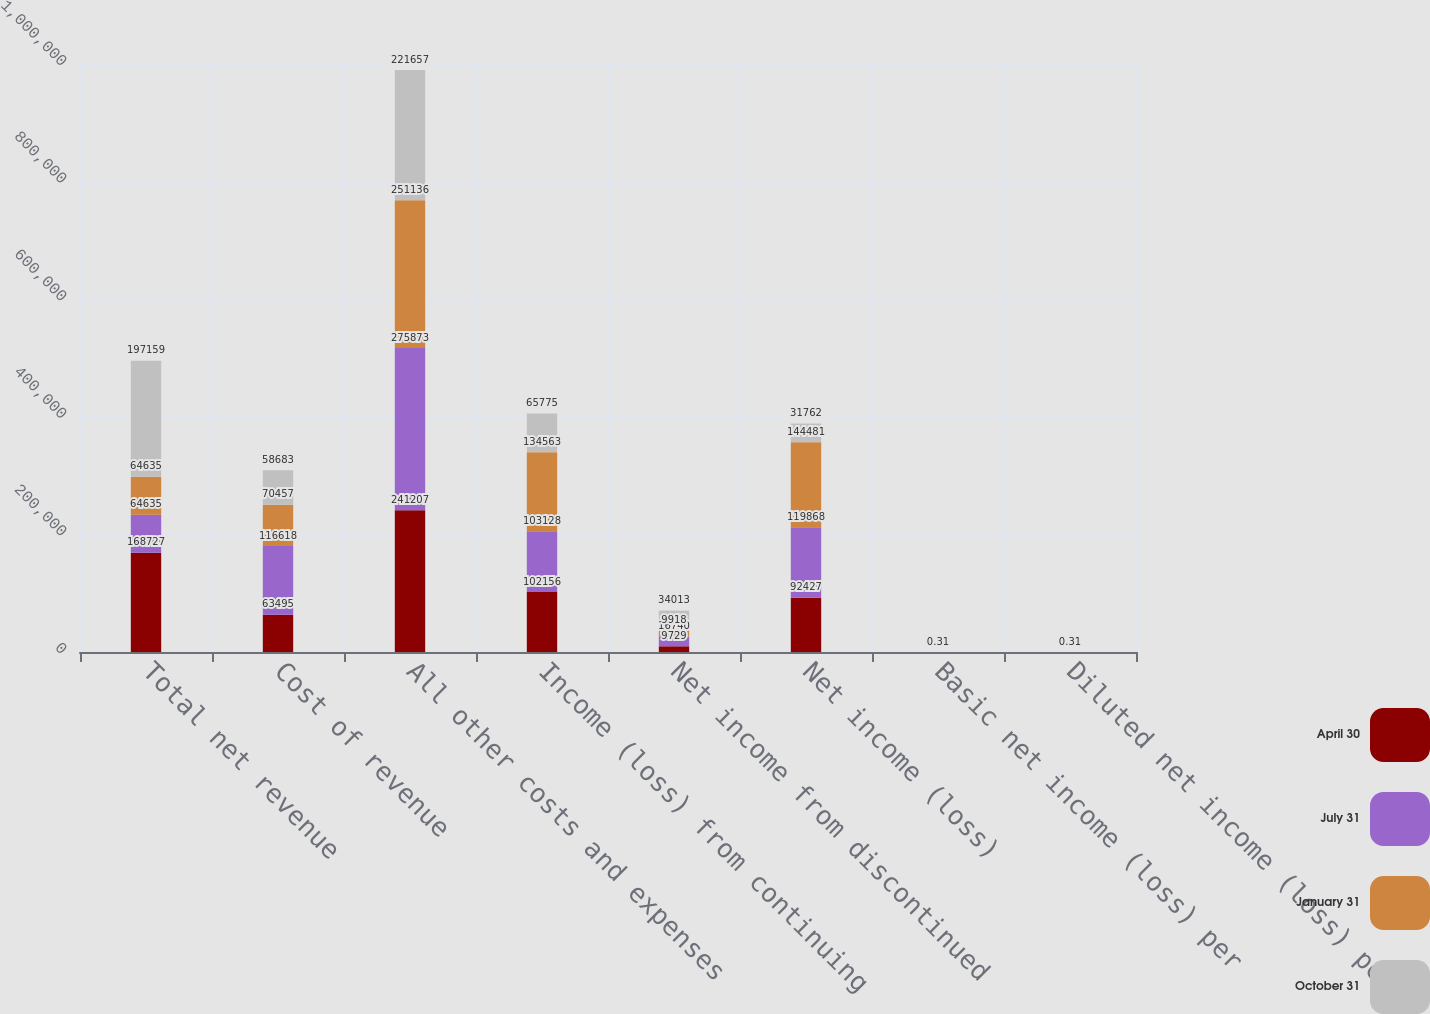Convert chart. <chart><loc_0><loc_0><loc_500><loc_500><stacked_bar_chart><ecel><fcel>Total net revenue<fcel>Cost of revenue<fcel>All other costs and expenses<fcel>Income (loss) from continuing<fcel>Net income from discontinued<fcel>Net income (loss)<fcel>Basic net income (loss) per<fcel>Diluted net income (loss) per<nl><fcel>April 30<fcel>168727<fcel>63495<fcel>241207<fcel>102156<fcel>9729<fcel>92427<fcel>0.48<fcel>0.48<nl><fcel>July 31<fcel>64635<fcel>116618<fcel>275873<fcel>103128<fcel>16740<fcel>119868<fcel>0.48<fcel>0.47<nl><fcel>January 31<fcel>64635<fcel>70457<fcel>251136<fcel>134563<fcel>9918<fcel>144481<fcel>0.63<fcel>0.62<nl><fcel>October 31<fcel>197159<fcel>58683<fcel>221657<fcel>65775<fcel>34013<fcel>31762<fcel>0.31<fcel>0.31<nl></chart> 